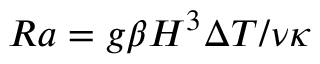<formula> <loc_0><loc_0><loc_500><loc_500>R a = g \beta H ^ { 3 } \Delta T / \nu \kappa</formula> 